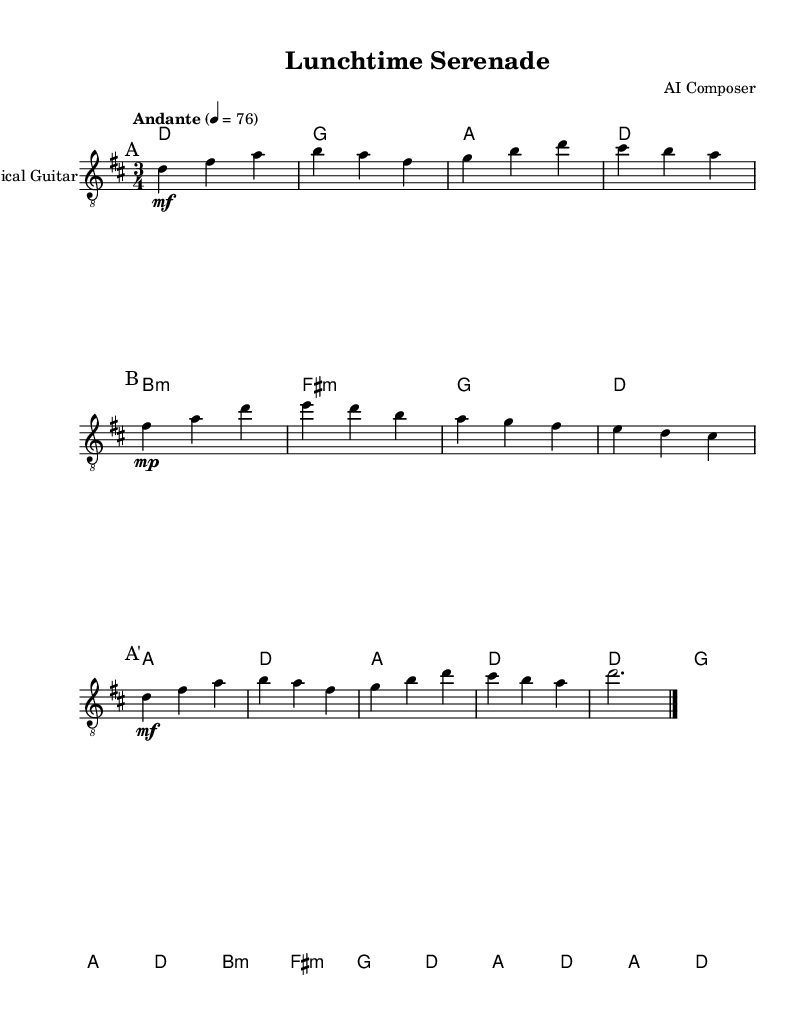What is the key signature of this music? The key signature is D major, which has two sharps: F# and C#.
Answer: D major What is the time signature for this piece? The time signature is 3/4, indicating three beats per measure.
Answer: 3/4 What is the tempo marking in this music? The tempo marking is "Andante," which indicates a moderate pace.
Answer: Andante How many total measures are in section A? Section A has a total of 6 measures, as indicated by the repeat structure and the notation.
Answer: 6 measures What type of guitar is specified for the performance? The specified instrument for this piece is a classical guitar, which is indicated in the staff settings.
Answer: Classical guitar What is the dynamic marking for the first section A? The dynamic marking for the first section A is mezzo-forte, shown by the "mf" notation under the notes.
Answer: mezzo-forte How many chords are indicated in the harmony part? There are a total of 10 chords indicated in the harmony part throughout the piece.
Answer: 10 chords 